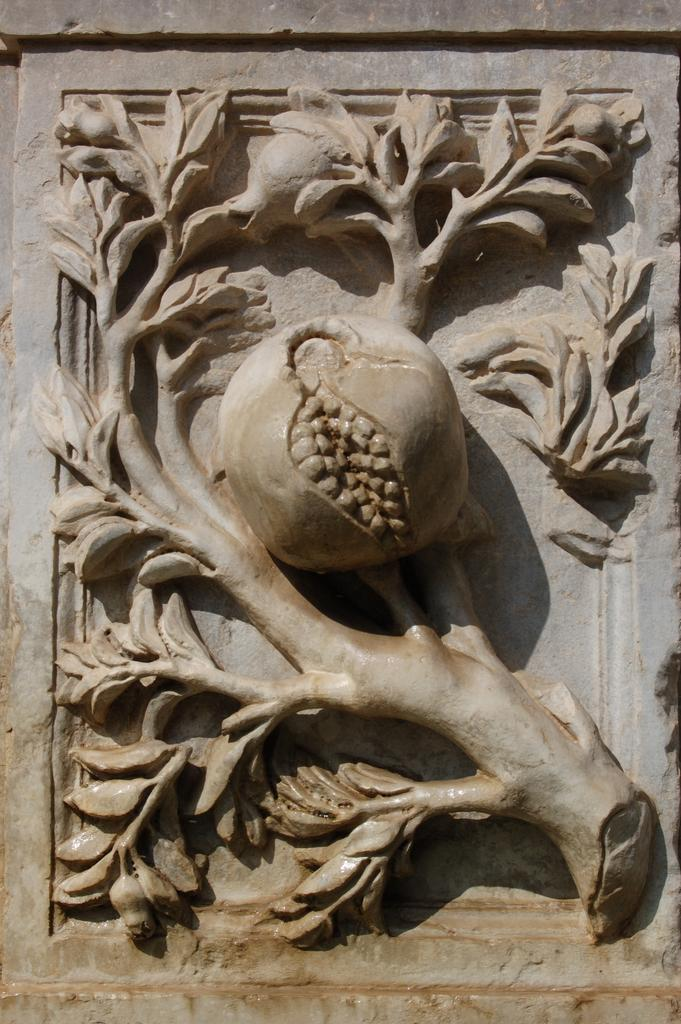What is the main subject of the image? The main subject of the image is a stone. What is unique about the stone's appearance? The stone is carved in the shape of a plant. What additional details can be seen on the stone? Flowers are depicted on the stone. Can you tell me how many times the stone smiles in the image? The stone does not have the ability to smile, as it is an inanimate object. 